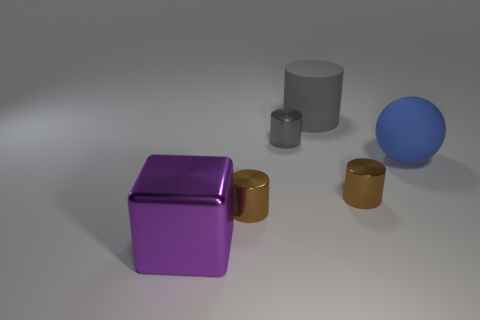Subtract all tiny gray cylinders. How many cylinders are left? 3 Add 3 tiny things. How many objects exist? 9 Subtract all gray spheres. How many brown cylinders are left? 2 Subtract all gray cylinders. How many cylinders are left? 2 Subtract all balls. How many objects are left? 5 Add 1 matte things. How many matte things are left? 3 Add 3 small brown metallic things. How many small brown metallic things exist? 5 Subtract 0 red balls. How many objects are left? 6 Subtract 1 balls. How many balls are left? 0 Subtract all gray cubes. Subtract all yellow cylinders. How many cubes are left? 1 